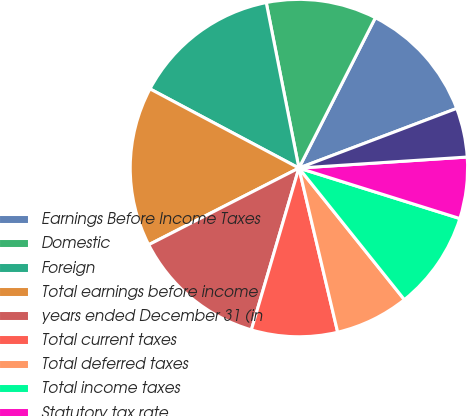<chart> <loc_0><loc_0><loc_500><loc_500><pie_chart><fcel>Earnings Before Income Taxes<fcel>Domestic<fcel>Foreign<fcel>Total earnings before income<fcel>years ended December 31 (in<fcel>Total current taxes<fcel>Total deferred taxes<fcel>Total income taxes<fcel>Statutory tax rate<fcel>Effect of foreign operations<nl><fcel>11.76%<fcel>10.59%<fcel>14.12%<fcel>15.29%<fcel>12.94%<fcel>8.24%<fcel>7.06%<fcel>9.41%<fcel>5.88%<fcel>4.71%<nl></chart> 